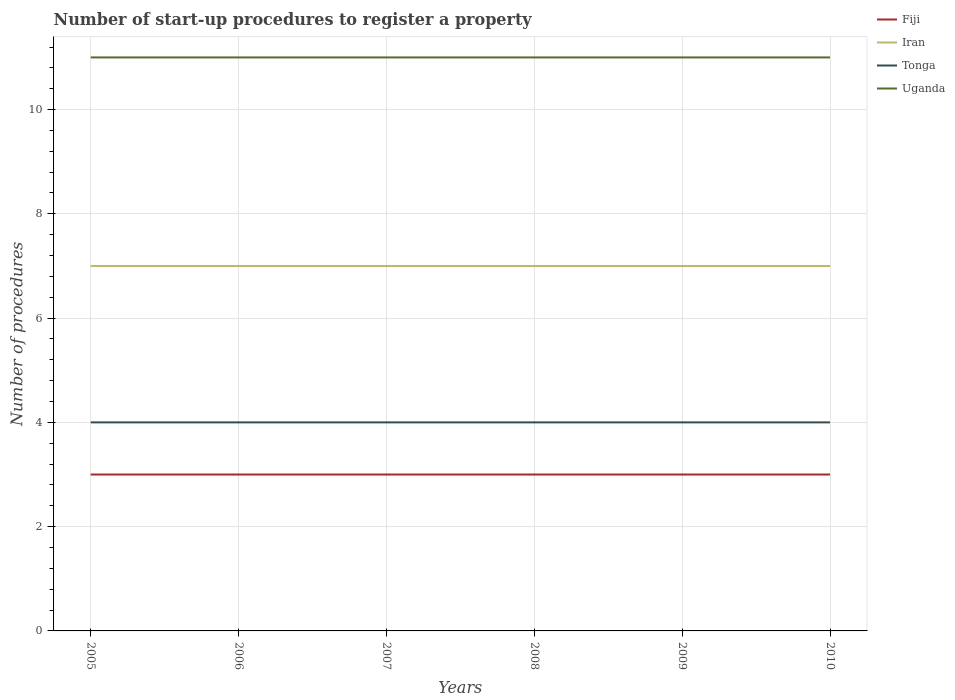Is the number of lines equal to the number of legend labels?
Your answer should be very brief. Yes. Across all years, what is the maximum number of procedures required to register a property in Uganda?
Your answer should be compact. 11. What is the difference between the highest and the second highest number of procedures required to register a property in Fiji?
Provide a short and direct response. 0. What is the difference between the highest and the lowest number of procedures required to register a property in Tonga?
Provide a succinct answer. 0. How many years are there in the graph?
Make the answer very short. 6. Are the values on the major ticks of Y-axis written in scientific E-notation?
Your answer should be compact. No. Does the graph contain grids?
Your answer should be very brief. Yes. Where does the legend appear in the graph?
Your response must be concise. Top right. How many legend labels are there?
Ensure brevity in your answer.  4. What is the title of the graph?
Your answer should be very brief. Number of start-up procedures to register a property. Does "Other small states" appear as one of the legend labels in the graph?
Keep it short and to the point. No. What is the label or title of the X-axis?
Your response must be concise. Years. What is the label or title of the Y-axis?
Give a very brief answer. Number of procedures. What is the Number of procedures in Fiji in 2005?
Make the answer very short. 3. What is the Number of procedures of Tonga in 2005?
Offer a terse response. 4. What is the Number of procedures of Uganda in 2005?
Give a very brief answer. 11. What is the Number of procedures in Iran in 2006?
Keep it short and to the point. 7. What is the Number of procedures in Iran in 2007?
Offer a very short reply. 7. What is the Number of procedures in Uganda in 2007?
Provide a succinct answer. 11. What is the Number of procedures in Fiji in 2008?
Ensure brevity in your answer.  3. What is the Number of procedures of Tonga in 2008?
Offer a very short reply. 4. What is the Number of procedures in Iran in 2009?
Your answer should be compact. 7. What is the Number of procedures of Tonga in 2009?
Offer a terse response. 4. What is the Number of procedures of Iran in 2010?
Offer a very short reply. 7. What is the Number of procedures in Uganda in 2010?
Make the answer very short. 11. Across all years, what is the minimum Number of procedures in Fiji?
Offer a very short reply. 3. Across all years, what is the minimum Number of procedures of Tonga?
Offer a terse response. 4. Across all years, what is the minimum Number of procedures in Uganda?
Your answer should be very brief. 11. What is the difference between the Number of procedures in Fiji in 2005 and that in 2006?
Your answer should be compact. 0. What is the difference between the Number of procedures in Iran in 2005 and that in 2006?
Your answer should be compact. 0. What is the difference between the Number of procedures of Uganda in 2005 and that in 2006?
Provide a succinct answer. 0. What is the difference between the Number of procedures in Uganda in 2005 and that in 2008?
Provide a short and direct response. 0. What is the difference between the Number of procedures of Tonga in 2005 and that in 2009?
Keep it short and to the point. 0. What is the difference between the Number of procedures of Uganda in 2005 and that in 2009?
Provide a succinct answer. 0. What is the difference between the Number of procedures of Fiji in 2005 and that in 2010?
Provide a succinct answer. 0. What is the difference between the Number of procedures in Tonga in 2005 and that in 2010?
Keep it short and to the point. 0. What is the difference between the Number of procedures of Uganda in 2005 and that in 2010?
Your response must be concise. 0. What is the difference between the Number of procedures in Fiji in 2006 and that in 2007?
Offer a terse response. 0. What is the difference between the Number of procedures in Uganda in 2006 and that in 2007?
Your answer should be very brief. 0. What is the difference between the Number of procedures of Iran in 2006 and that in 2008?
Your answer should be compact. 0. What is the difference between the Number of procedures of Uganda in 2006 and that in 2008?
Your response must be concise. 0. What is the difference between the Number of procedures of Fiji in 2006 and that in 2009?
Keep it short and to the point. 0. What is the difference between the Number of procedures of Iran in 2006 and that in 2009?
Provide a short and direct response. 0. What is the difference between the Number of procedures in Fiji in 2006 and that in 2010?
Provide a succinct answer. 0. What is the difference between the Number of procedures in Uganda in 2006 and that in 2010?
Provide a succinct answer. 0. What is the difference between the Number of procedures in Fiji in 2007 and that in 2008?
Keep it short and to the point. 0. What is the difference between the Number of procedures in Iran in 2007 and that in 2008?
Ensure brevity in your answer.  0. What is the difference between the Number of procedures in Uganda in 2007 and that in 2008?
Your response must be concise. 0. What is the difference between the Number of procedures in Fiji in 2007 and that in 2009?
Ensure brevity in your answer.  0. What is the difference between the Number of procedures of Iran in 2007 and that in 2009?
Your response must be concise. 0. What is the difference between the Number of procedures of Fiji in 2007 and that in 2010?
Offer a terse response. 0. What is the difference between the Number of procedures in Iran in 2007 and that in 2010?
Offer a very short reply. 0. What is the difference between the Number of procedures in Tonga in 2007 and that in 2010?
Your response must be concise. 0. What is the difference between the Number of procedures of Uganda in 2008 and that in 2009?
Keep it short and to the point. 0. What is the difference between the Number of procedures in Fiji in 2008 and that in 2010?
Provide a succinct answer. 0. What is the difference between the Number of procedures of Uganda in 2008 and that in 2010?
Your response must be concise. 0. What is the difference between the Number of procedures of Fiji in 2009 and that in 2010?
Keep it short and to the point. 0. What is the difference between the Number of procedures in Fiji in 2005 and the Number of procedures in Uganda in 2006?
Your response must be concise. -8. What is the difference between the Number of procedures in Fiji in 2005 and the Number of procedures in Iran in 2007?
Give a very brief answer. -4. What is the difference between the Number of procedures in Fiji in 2005 and the Number of procedures in Uganda in 2007?
Provide a short and direct response. -8. What is the difference between the Number of procedures in Iran in 2005 and the Number of procedures in Tonga in 2007?
Offer a very short reply. 3. What is the difference between the Number of procedures in Iran in 2005 and the Number of procedures in Uganda in 2007?
Your answer should be very brief. -4. What is the difference between the Number of procedures in Tonga in 2005 and the Number of procedures in Uganda in 2007?
Offer a terse response. -7. What is the difference between the Number of procedures of Fiji in 2005 and the Number of procedures of Uganda in 2008?
Your answer should be compact. -8. What is the difference between the Number of procedures in Iran in 2005 and the Number of procedures in Tonga in 2008?
Give a very brief answer. 3. What is the difference between the Number of procedures in Iran in 2005 and the Number of procedures in Uganda in 2008?
Your response must be concise. -4. What is the difference between the Number of procedures of Tonga in 2005 and the Number of procedures of Uganda in 2008?
Ensure brevity in your answer.  -7. What is the difference between the Number of procedures in Fiji in 2005 and the Number of procedures in Iran in 2009?
Keep it short and to the point. -4. What is the difference between the Number of procedures of Iran in 2005 and the Number of procedures of Tonga in 2009?
Provide a succinct answer. 3. What is the difference between the Number of procedures of Fiji in 2005 and the Number of procedures of Iran in 2010?
Provide a short and direct response. -4. What is the difference between the Number of procedures of Tonga in 2005 and the Number of procedures of Uganda in 2010?
Give a very brief answer. -7. What is the difference between the Number of procedures of Fiji in 2006 and the Number of procedures of Iran in 2007?
Offer a terse response. -4. What is the difference between the Number of procedures in Iran in 2006 and the Number of procedures in Uganda in 2007?
Offer a very short reply. -4. What is the difference between the Number of procedures of Tonga in 2006 and the Number of procedures of Uganda in 2007?
Provide a succinct answer. -7. What is the difference between the Number of procedures in Fiji in 2006 and the Number of procedures in Iran in 2008?
Give a very brief answer. -4. What is the difference between the Number of procedures in Fiji in 2006 and the Number of procedures in Tonga in 2008?
Provide a short and direct response. -1. What is the difference between the Number of procedures in Fiji in 2006 and the Number of procedures in Iran in 2009?
Your answer should be compact. -4. What is the difference between the Number of procedures in Fiji in 2006 and the Number of procedures in Iran in 2010?
Your response must be concise. -4. What is the difference between the Number of procedures of Fiji in 2006 and the Number of procedures of Tonga in 2010?
Give a very brief answer. -1. What is the difference between the Number of procedures of Fiji in 2006 and the Number of procedures of Uganda in 2010?
Your response must be concise. -8. What is the difference between the Number of procedures in Iran in 2006 and the Number of procedures in Tonga in 2010?
Offer a terse response. 3. What is the difference between the Number of procedures in Iran in 2006 and the Number of procedures in Uganda in 2010?
Offer a very short reply. -4. What is the difference between the Number of procedures of Tonga in 2006 and the Number of procedures of Uganda in 2010?
Offer a very short reply. -7. What is the difference between the Number of procedures in Fiji in 2007 and the Number of procedures in Iran in 2008?
Give a very brief answer. -4. What is the difference between the Number of procedures in Fiji in 2007 and the Number of procedures in Tonga in 2008?
Your response must be concise. -1. What is the difference between the Number of procedures of Fiji in 2007 and the Number of procedures of Uganda in 2008?
Your answer should be very brief. -8. What is the difference between the Number of procedures of Iran in 2007 and the Number of procedures of Uganda in 2008?
Provide a succinct answer. -4. What is the difference between the Number of procedures in Tonga in 2007 and the Number of procedures in Uganda in 2008?
Ensure brevity in your answer.  -7. What is the difference between the Number of procedures of Fiji in 2007 and the Number of procedures of Iran in 2009?
Give a very brief answer. -4. What is the difference between the Number of procedures of Fiji in 2007 and the Number of procedures of Uganda in 2009?
Keep it short and to the point. -8. What is the difference between the Number of procedures in Tonga in 2007 and the Number of procedures in Uganda in 2009?
Ensure brevity in your answer.  -7. What is the difference between the Number of procedures in Fiji in 2007 and the Number of procedures in Iran in 2010?
Make the answer very short. -4. What is the difference between the Number of procedures of Fiji in 2007 and the Number of procedures of Tonga in 2010?
Keep it short and to the point. -1. What is the difference between the Number of procedures in Iran in 2007 and the Number of procedures in Tonga in 2010?
Offer a terse response. 3. What is the difference between the Number of procedures of Iran in 2007 and the Number of procedures of Uganda in 2010?
Ensure brevity in your answer.  -4. What is the difference between the Number of procedures in Fiji in 2008 and the Number of procedures in Iran in 2009?
Offer a very short reply. -4. What is the difference between the Number of procedures of Fiji in 2008 and the Number of procedures of Uganda in 2009?
Your answer should be very brief. -8. What is the difference between the Number of procedures in Iran in 2008 and the Number of procedures in Uganda in 2009?
Your answer should be compact. -4. What is the difference between the Number of procedures in Fiji in 2008 and the Number of procedures in Tonga in 2010?
Provide a succinct answer. -1. What is the difference between the Number of procedures in Fiji in 2008 and the Number of procedures in Uganda in 2010?
Ensure brevity in your answer.  -8. What is the difference between the Number of procedures of Iran in 2008 and the Number of procedures of Tonga in 2010?
Provide a short and direct response. 3. What is the difference between the Number of procedures of Tonga in 2008 and the Number of procedures of Uganda in 2010?
Ensure brevity in your answer.  -7. What is the difference between the Number of procedures in Fiji in 2009 and the Number of procedures in Tonga in 2010?
Your answer should be compact. -1. What is the difference between the Number of procedures in Fiji in 2009 and the Number of procedures in Uganda in 2010?
Provide a short and direct response. -8. What is the difference between the Number of procedures in Iran in 2009 and the Number of procedures in Tonga in 2010?
Your response must be concise. 3. What is the difference between the Number of procedures of Tonga in 2009 and the Number of procedures of Uganda in 2010?
Your answer should be compact. -7. What is the average Number of procedures in Uganda per year?
Provide a succinct answer. 11. In the year 2005, what is the difference between the Number of procedures in Fiji and Number of procedures in Iran?
Your answer should be very brief. -4. In the year 2005, what is the difference between the Number of procedures of Fiji and Number of procedures of Tonga?
Give a very brief answer. -1. In the year 2005, what is the difference between the Number of procedures in Fiji and Number of procedures in Uganda?
Ensure brevity in your answer.  -8. In the year 2006, what is the difference between the Number of procedures of Fiji and Number of procedures of Tonga?
Ensure brevity in your answer.  -1. In the year 2006, what is the difference between the Number of procedures in Fiji and Number of procedures in Uganda?
Ensure brevity in your answer.  -8. In the year 2007, what is the difference between the Number of procedures in Fiji and Number of procedures in Iran?
Your answer should be compact. -4. In the year 2007, what is the difference between the Number of procedures in Fiji and Number of procedures in Tonga?
Make the answer very short. -1. In the year 2007, what is the difference between the Number of procedures of Iran and Number of procedures of Tonga?
Offer a very short reply. 3. In the year 2007, what is the difference between the Number of procedures in Iran and Number of procedures in Uganda?
Provide a succinct answer. -4. In the year 2008, what is the difference between the Number of procedures of Fiji and Number of procedures of Tonga?
Offer a very short reply. -1. In the year 2008, what is the difference between the Number of procedures in Tonga and Number of procedures in Uganda?
Offer a very short reply. -7. In the year 2010, what is the difference between the Number of procedures in Fiji and Number of procedures in Iran?
Offer a very short reply. -4. In the year 2010, what is the difference between the Number of procedures of Fiji and Number of procedures of Tonga?
Your answer should be compact. -1. In the year 2010, what is the difference between the Number of procedures in Iran and Number of procedures in Tonga?
Give a very brief answer. 3. What is the ratio of the Number of procedures in Fiji in 2005 to that in 2006?
Ensure brevity in your answer.  1. What is the ratio of the Number of procedures in Tonga in 2005 to that in 2007?
Keep it short and to the point. 1. What is the ratio of the Number of procedures of Uganda in 2005 to that in 2007?
Keep it short and to the point. 1. What is the ratio of the Number of procedures in Fiji in 2005 to that in 2008?
Make the answer very short. 1. What is the ratio of the Number of procedures in Iran in 2005 to that in 2008?
Offer a terse response. 1. What is the ratio of the Number of procedures of Uganda in 2005 to that in 2008?
Keep it short and to the point. 1. What is the ratio of the Number of procedures of Fiji in 2005 to that in 2009?
Give a very brief answer. 1. What is the ratio of the Number of procedures in Iran in 2005 to that in 2009?
Give a very brief answer. 1. What is the ratio of the Number of procedures of Iran in 2005 to that in 2010?
Make the answer very short. 1. What is the ratio of the Number of procedures of Tonga in 2005 to that in 2010?
Offer a very short reply. 1. What is the ratio of the Number of procedures of Fiji in 2006 to that in 2007?
Your answer should be very brief. 1. What is the ratio of the Number of procedures in Iran in 2006 to that in 2007?
Provide a short and direct response. 1. What is the ratio of the Number of procedures of Tonga in 2006 to that in 2007?
Offer a very short reply. 1. What is the ratio of the Number of procedures in Fiji in 2006 to that in 2008?
Keep it short and to the point. 1. What is the ratio of the Number of procedures of Iran in 2006 to that in 2008?
Keep it short and to the point. 1. What is the ratio of the Number of procedures in Uganda in 2006 to that in 2008?
Your answer should be compact. 1. What is the ratio of the Number of procedures in Tonga in 2006 to that in 2009?
Offer a terse response. 1. What is the ratio of the Number of procedures in Fiji in 2006 to that in 2010?
Provide a succinct answer. 1. What is the ratio of the Number of procedures in Iran in 2006 to that in 2010?
Offer a terse response. 1. What is the ratio of the Number of procedures of Fiji in 2007 to that in 2008?
Your response must be concise. 1. What is the ratio of the Number of procedures in Tonga in 2007 to that in 2008?
Provide a succinct answer. 1. What is the ratio of the Number of procedures in Uganda in 2007 to that in 2008?
Ensure brevity in your answer.  1. What is the ratio of the Number of procedures in Fiji in 2007 to that in 2009?
Ensure brevity in your answer.  1. What is the ratio of the Number of procedures of Tonga in 2007 to that in 2009?
Keep it short and to the point. 1. What is the ratio of the Number of procedures in Iran in 2007 to that in 2010?
Provide a short and direct response. 1. What is the ratio of the Number of procedures of Fiji in 2008 to that in 2009?
Your answer should be compact. 1. What is the ratio of the Number of procedures of Tonga in 2008 to that in 2009?
Ensure brevity in your answer.  1. What is the ratio of the Number of procedures of Fiji in 2008 to that in 2010?
Your answer should be compact. 1. What is the ratio of the Number of procedures in Tonga in 2008 to that in 2010?
Offer a terse response. 1. What is the ratio of the Number of procedures of Fiji in 2009 to that in 2010?
Provide a succinct answer. 1. What is the ratio of the Number of procedures in Iran in 2009 to that in 2010?
Make the answer very short. 1. What is the difference between the highest and the second highest Number of procedures of Fiji?
Make the answer very short. 0. What is the difference between the highest and the second highest Number of procedures in Iran?
Provide a short and direct response. 0. What is the difference between the highest and the second highest Number of procedures of Uganda?
Offer a terse response. 0. What is the difference between the highest and the lowest Number of procedures in Fiji?
Give a very brief answer. 0. 